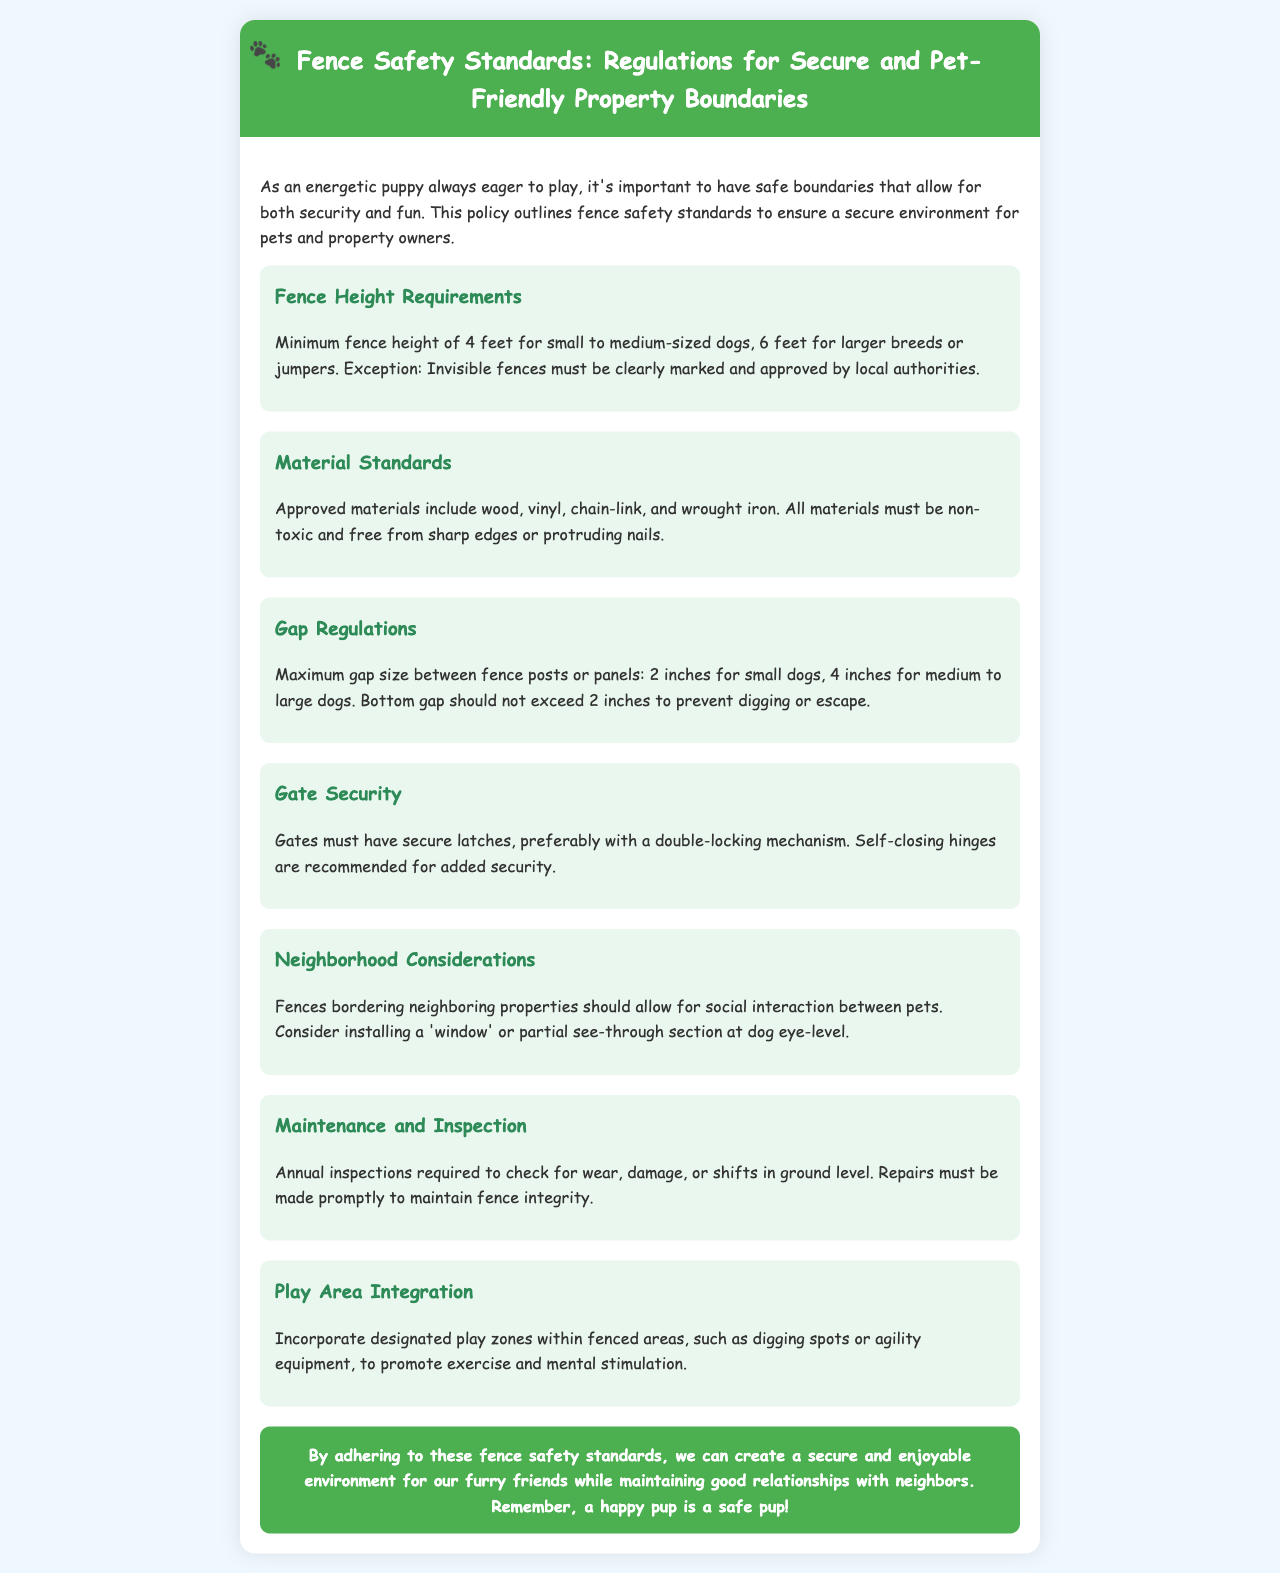What is the minimum fence height for small dogs? The document states that the minimum fence height for small to medium-sized dogs is 4 feet.
Answer: 4 feet What materials are approved for fences? The approved materials include wood, vinyl, chain-link, and wrought iron as mentioned in the material standards section.
Answer: wood, vinyl, chain-link, wrought iron What is the maximum gap size for small dogs? According to the gap regulations, the maximum gap size between fence posts or panels for small dogs is 2 inches.
Answer: 2 inches What is required for gate security? The document specifies that gates must have secure latches, preferably with a double-locking mechanism.
Answer: secure latches How often should fences be inspected? The maintenance section states that annual inspections are required to check for wear, damage, or shifts.
Answer: annually What is a recommended feature for fences bordering neighboring properties? The document suggests considering installing a 'window' or partial see-through section at dog eye-level for social interaction.
Answer: 'window' What type of exercise is promoted within fenced areas? The policy encourages incorporating designated play zones such as agility equipment to promote exercise and mental stimulation.
Answer: exercise What is the conclusion's main focus? The conclusion emphasizes creating a secure and enjoyable environment for pets while maintaining good relationships with neighbors.
Answer: secure and enjoyable environment 